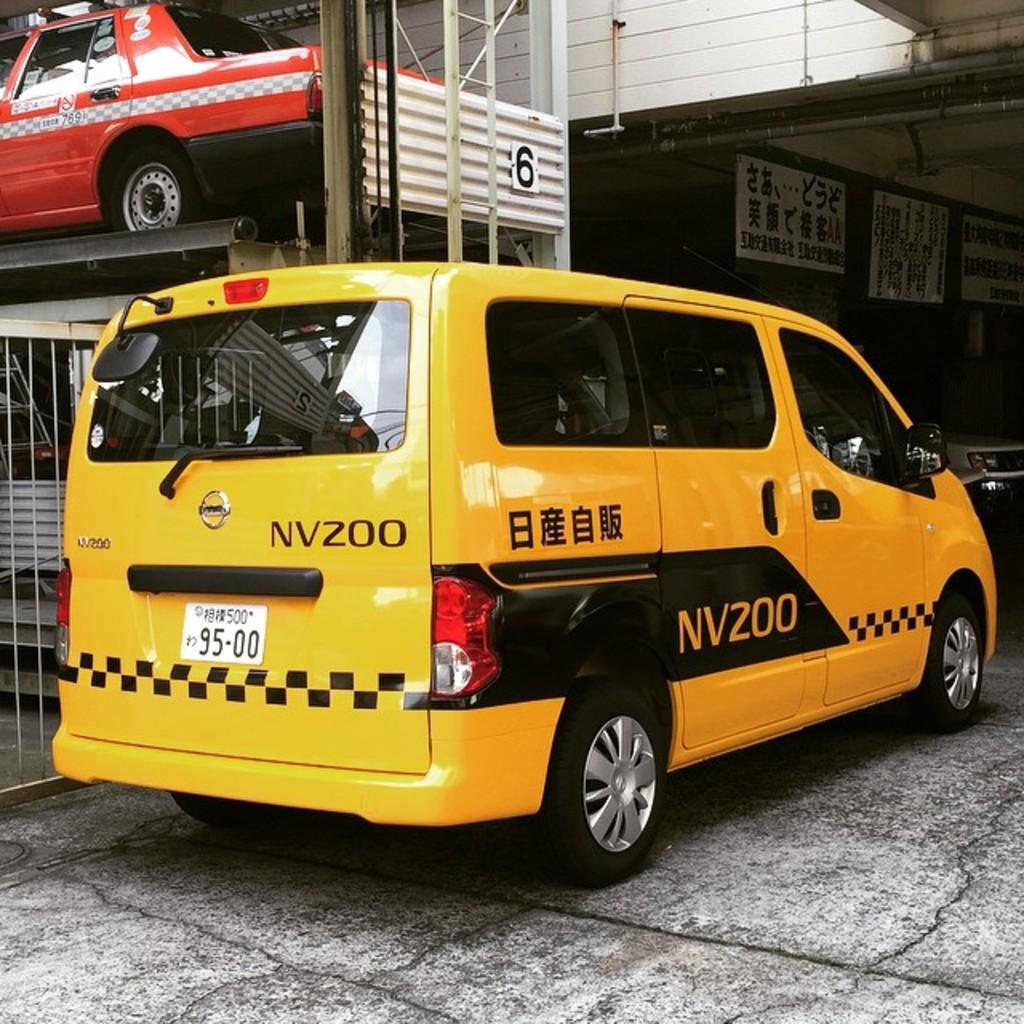In one or two sentences, can you explain what this image depicts? There are two cars present in the middle of this image. We can see posters and a wall in the background. There is a fence on the left side of this image. 